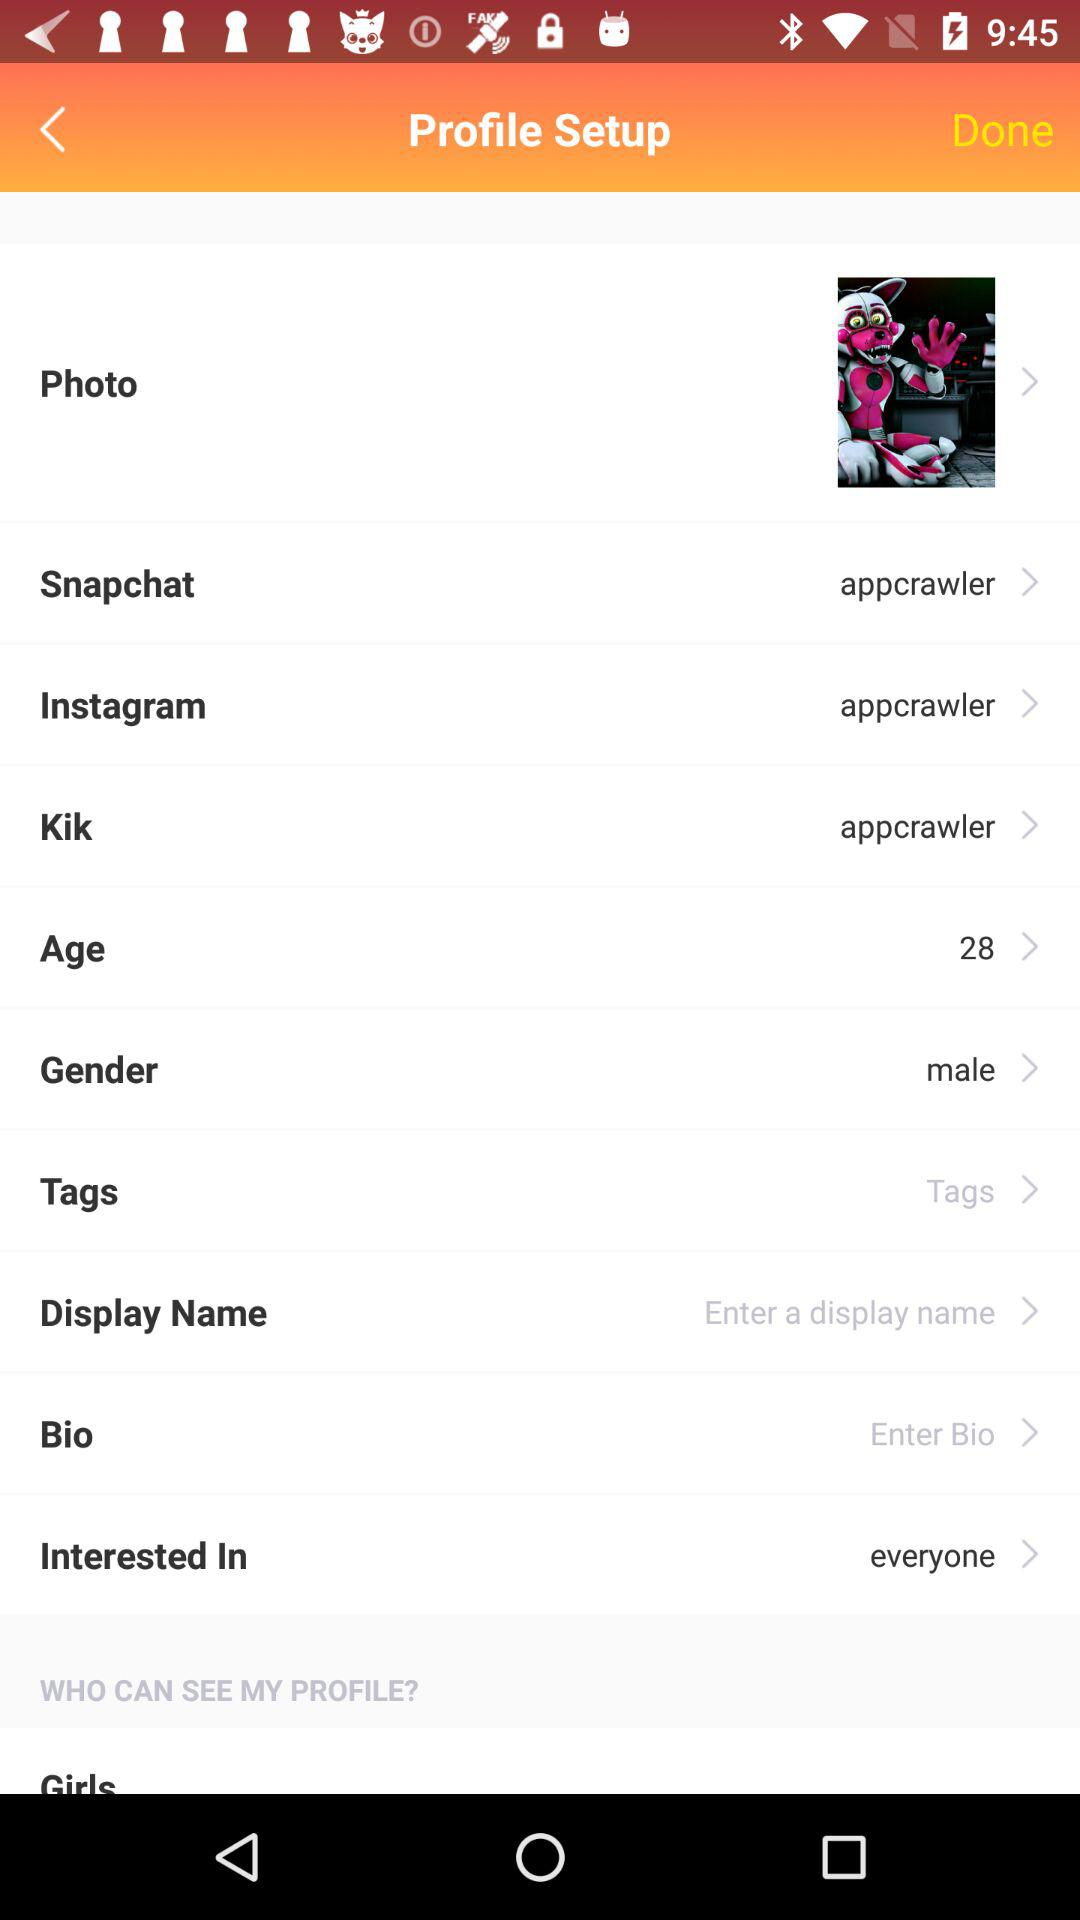How many items are on the profile setup screen?
Answer the question using a single word or phrase. 11 